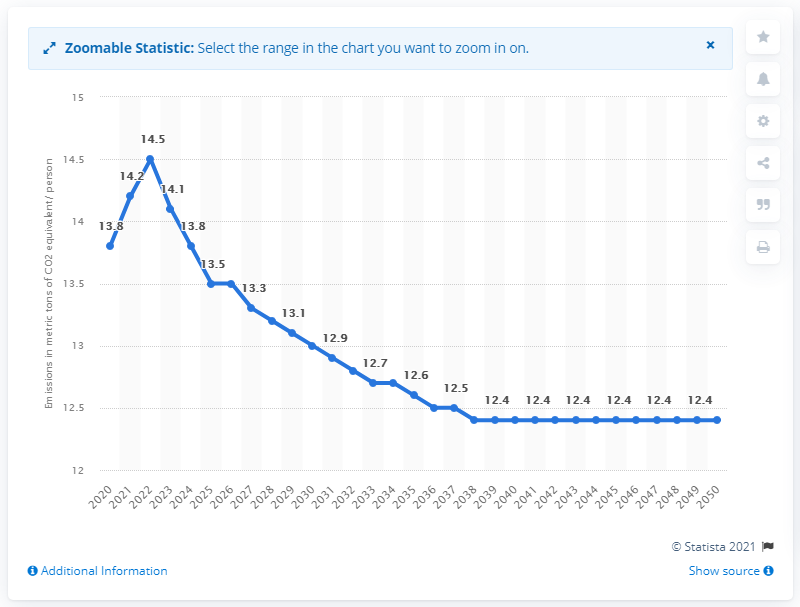Draw attention to some important aspects in this diagram. Emissions are expected to decrease beginning in 2022, according to projections. 